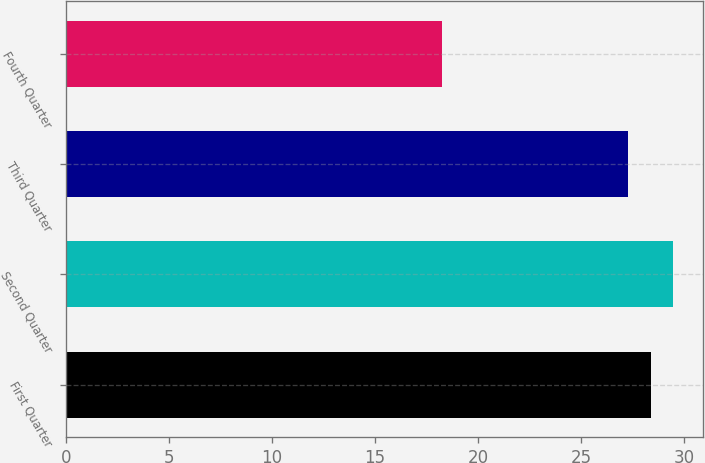Convert chart. <chart><loc_0><loc_0><loc_500><loc_500><bar_chart><fcel>First Quarter<fcel>Second Quarter<fcel>Third Quarter<fcel>Fourth Quarter<nl><fcel>28.37<fcel>29.45<fcel>27.29<fcel>18.25<nl></chart> 